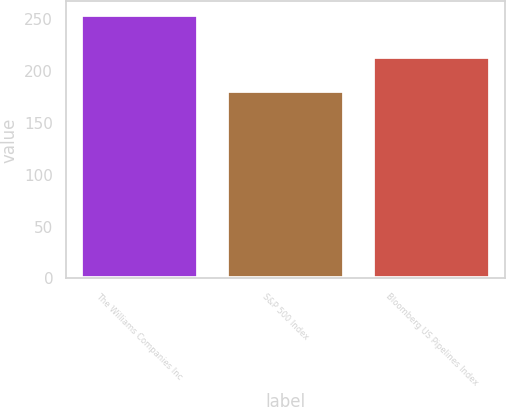Convert chart to OTSL. <chart><loc_0><loc_0><loc_500><loc_500><bar_chart><fcel>The Williams Companies Inc<fcel>S&P 500 Index<fcel>Bloomberg US Pipelines Index<nl><fcel>254.4<fcel>180.3<fcel>213.6<nl></chart> 